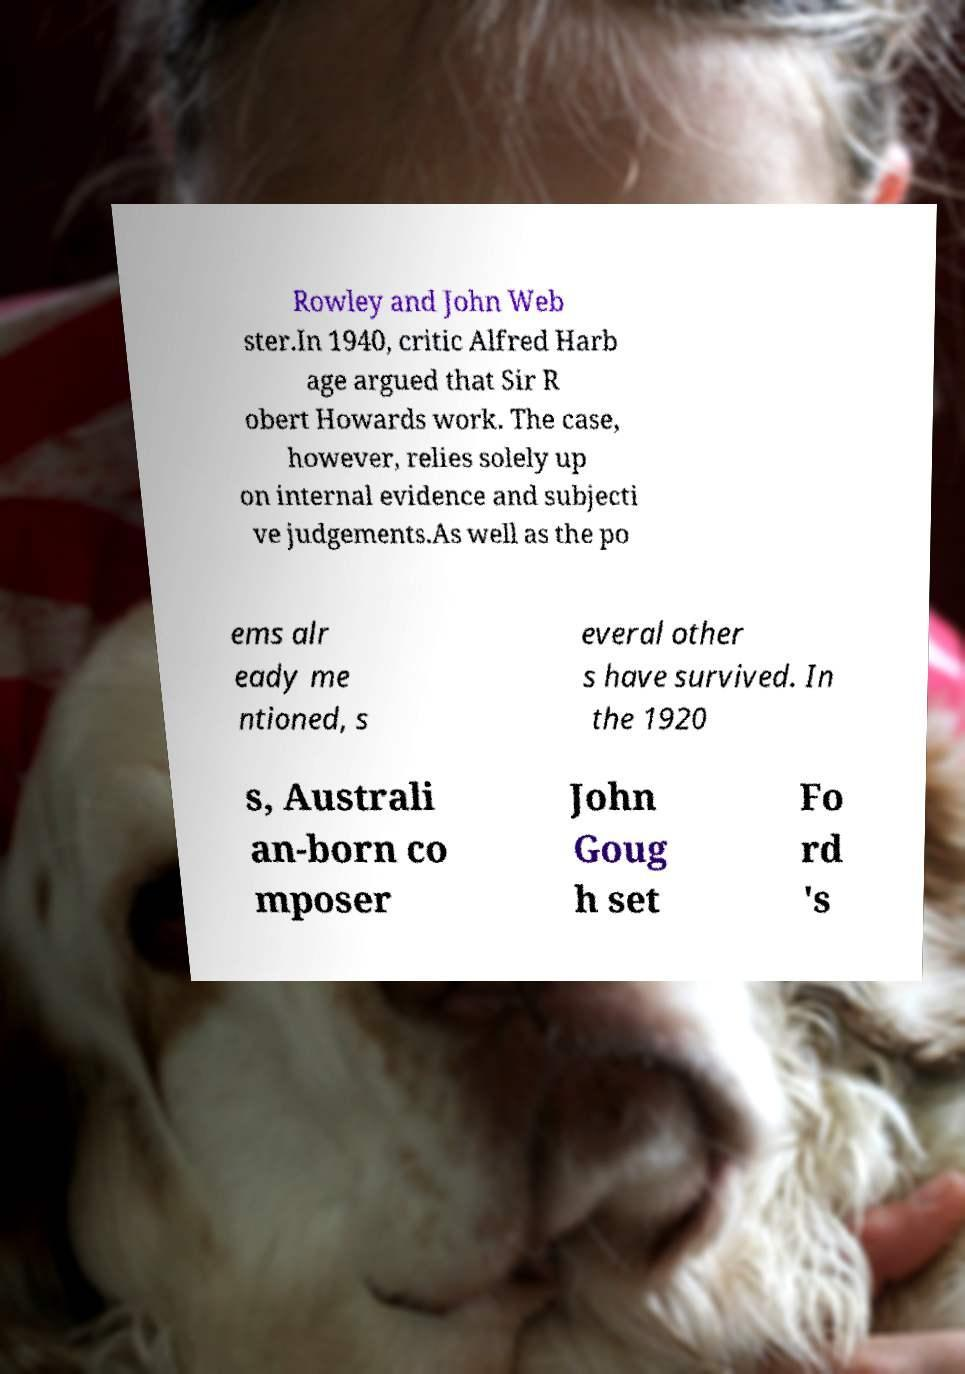Could you assist in decoding the text presented in this image and type it out clearly? Rowley and John Web ster.In 1940, critic Alfred Harb age argued that Sir R obert Howards work. The case, however, relies solely up on internal evidence and subjecti ve judgements.As well as the po ems alr eady me ntioned, s everal other s have survived. In the 1920 s, Australi an-born co mposer John Goug h set Fo rd 's 